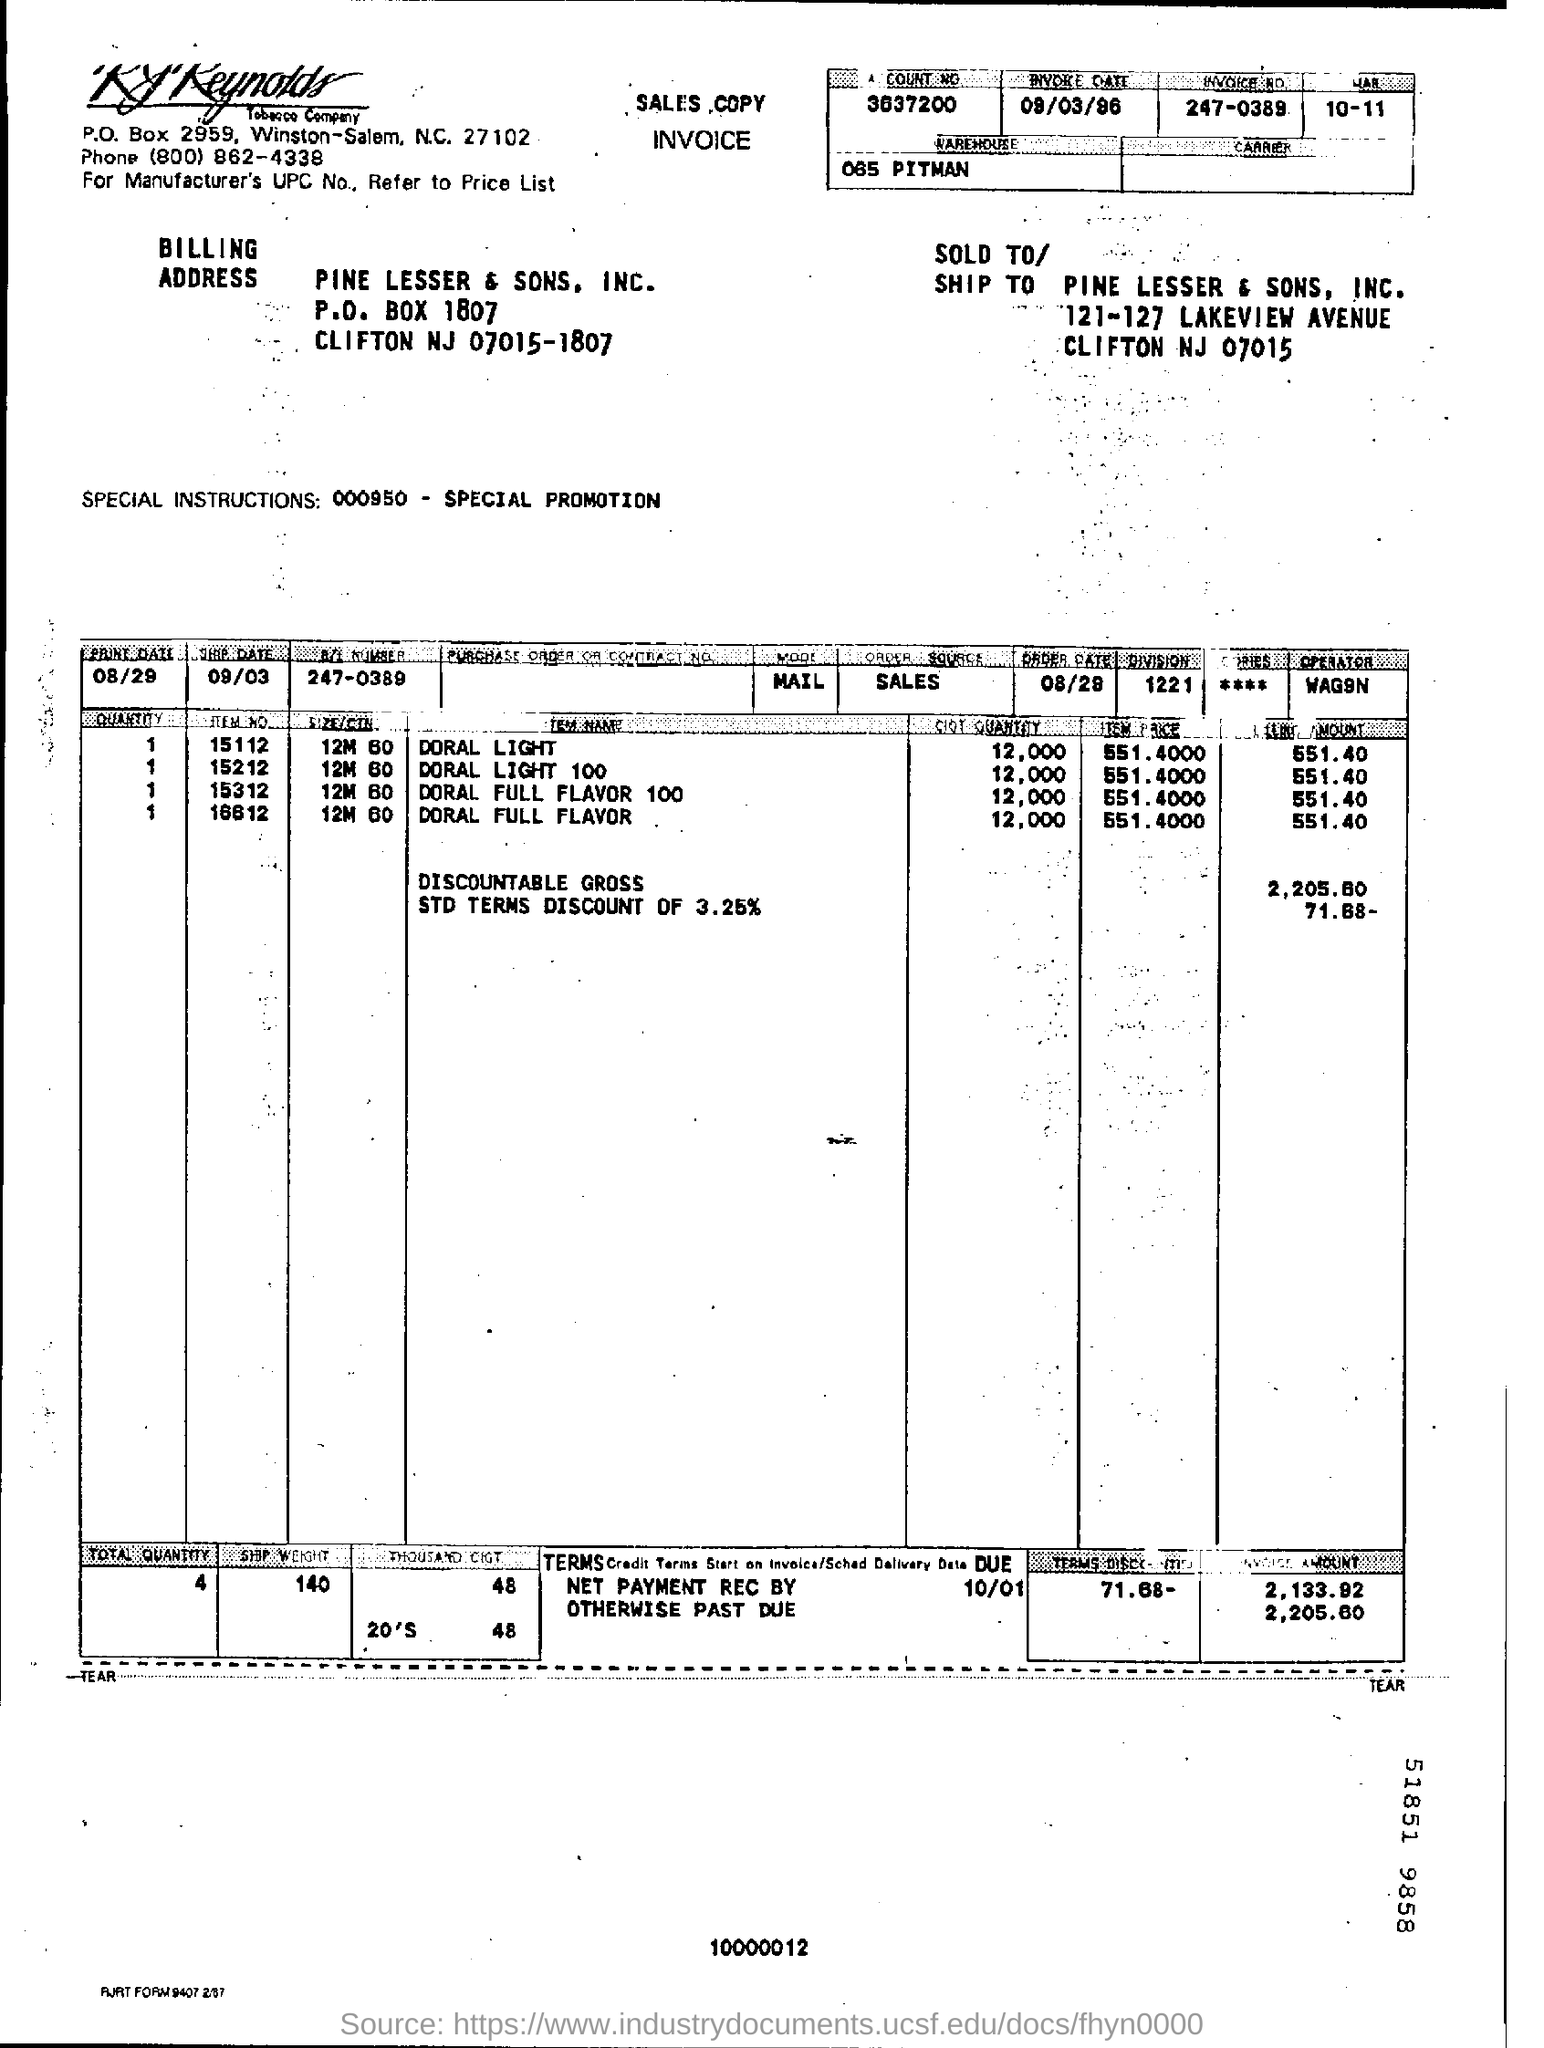Outline some significant characteristics in this image. On what date was the invoice issued? The invoice number is 247-0389. The Discountable Gross is 2,205.60. 